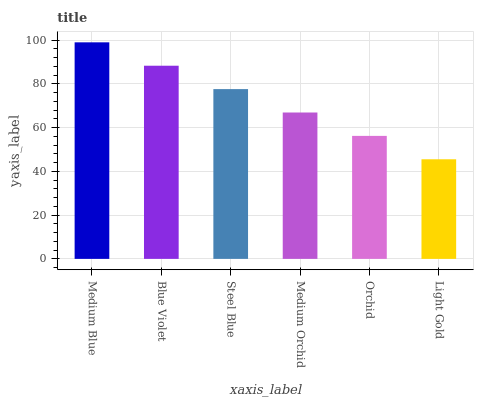Is Light Gold the minimum?
Answer yes or no. Yes. Is Medium Blue the maximum?
Answer yes or no. Yes. Is Blue Violet the minimum?
Answer yes or no. No. Is Blue Violet the maximum?
Answer yes or no. No. Is Medium Blue greater than Blue Violet?
Answer yes or no. Yes. Is Blue Violet less than Medium Blue?
Answer yes or no. Yes. Is Blue Violet greater than Medium Blue?
Answer yes or no. No. Is Medium Blue less than Blue Violet?
Answer yes or no. No. Is Steel Blue the high median?
Answer yes or no. Yes. Is Medium Orchid the low median?
Answer yes or no. Yes. Is Medium Orchid the high median?
Answer yes or no. No. Is Orchid the low median?
Answer yes or no. No. 